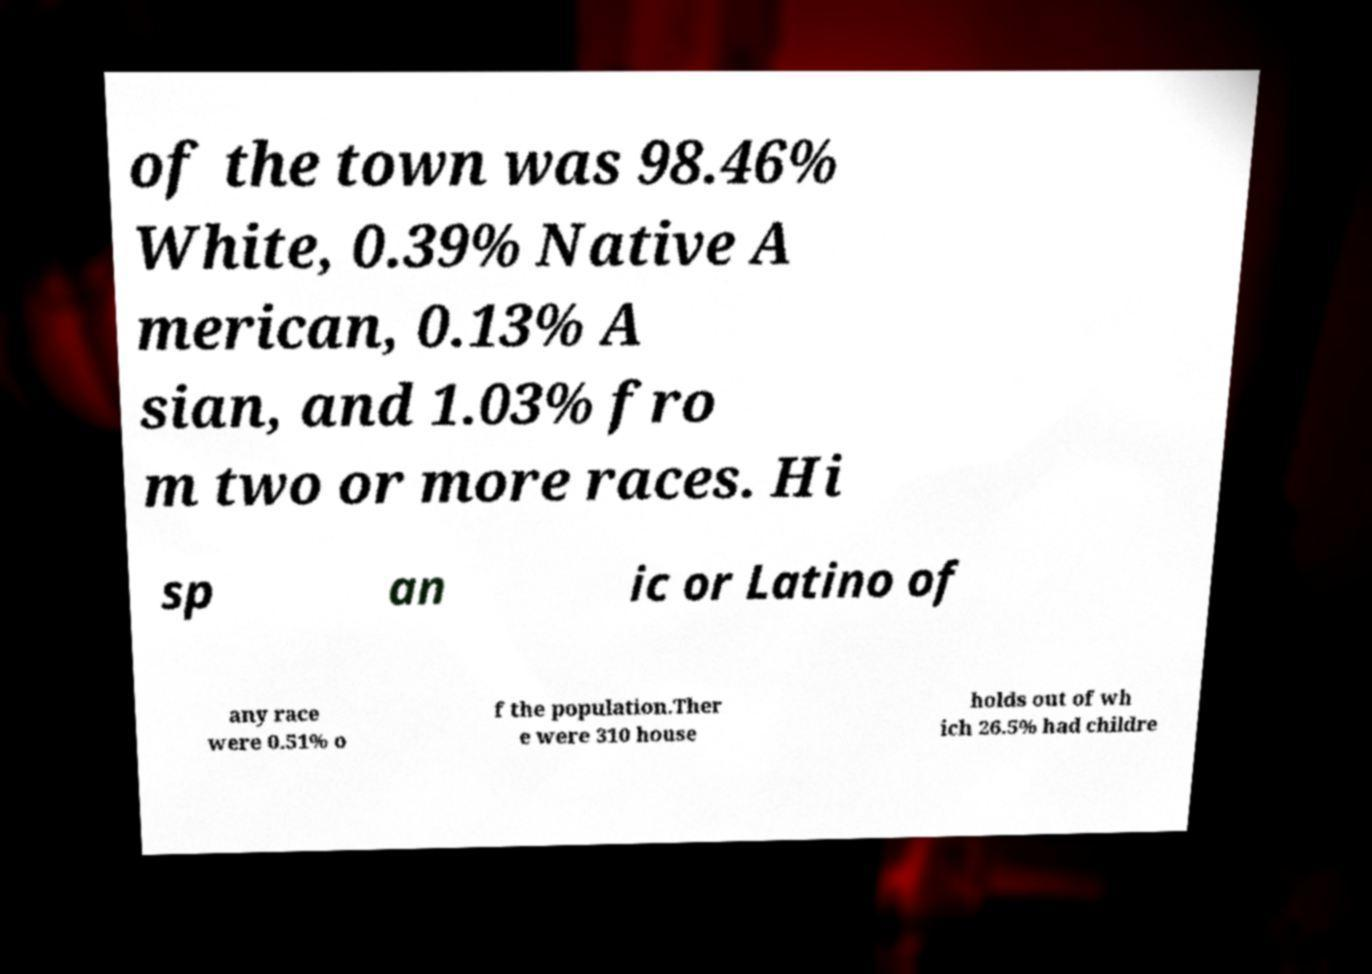Please read and relay the text visible in this image. What does it say? of the town was 98.46% White, 0.39% Native A merican, 0.13% A sian, and 1.03% fro m two or more races. Hi sp an ic or Latino of any race were 0.51% o f the population.Ther e were 310 house holds out of wh ich 26.5% had childre 